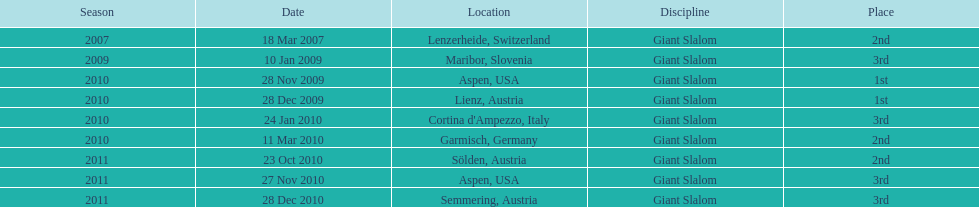The concluding race ending point was not 1st, but which different rank? 3rd. 